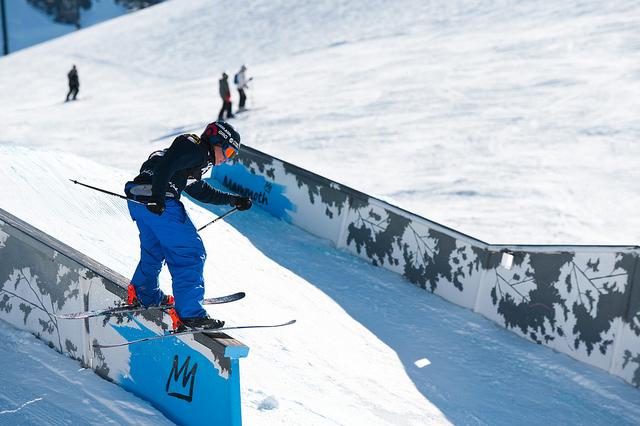Is it winter?
Write a very short answer. Yes. How many people are on the rail?
Short answer required. 1. What is on the ground?
Write a very short answer. Snow. 